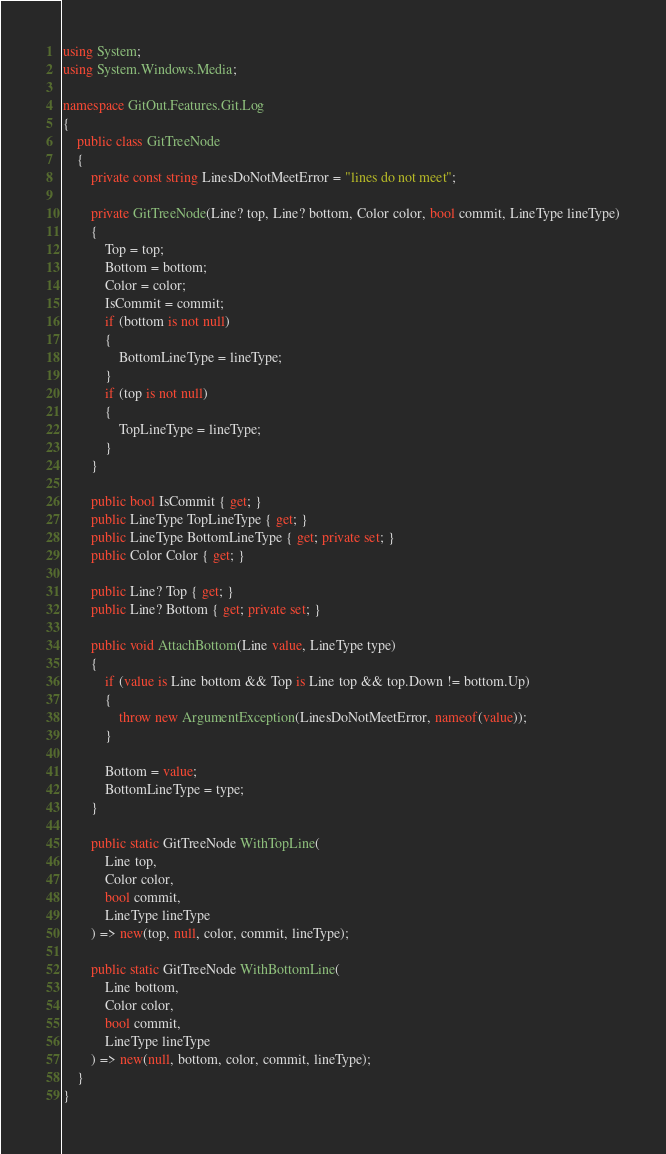<code> <loc_0><loc_0><loc_500><loc_500><_C#_>using System;
using System.Windows.Media;

namespace GitOut.Features.Git.Log
{
    public class GitTreeNode
    {
        private const string LinesDoNotMeetError = "lines do not meet";

        private GitTreeNode(Line? top, Line? bottom, Color color, bool commit, LineType lineType)
        {
            Top = top;
            Bottom = bottom;
            Color = color;
            IsCommit = commit;
            if (bottom is not null)
            {
                BottomLineType = lineType;
            }
            if (top is not null)
            {
                TopLineType = lineType;
            }
        }

        public bool IsCommit { get; }
        public LineType TopLineType { get; }
        public LineType BottomLineType { get; private set; }
        public Color Color { get; }

        public Line? Top { get; }
        public Line? Bottom { get; private set; }

        public void AttachBottom(Line value, LineType type)
        {
            if (value is Line bottom && Top is Line top && top.Down != bottom.Up)
            {
                throw new ArgumentException(LinesDoNotMeetError, nameof(value));
            }

            Bottom = value;
            BottomLineType = type;
        }

        public static GitTreeNode WithTopLine(
            Line top,
            Color color,
            bool commit,
            LineType lineType
        ) => new(top, null, color, commit, lineType);

        public static GitTreeNode WithBottomLine(
            Line bottom,
            Color color,
            bool commit,
            LineType lineType
        ) => new(null, bottom, color, commit, lineType);
    }
}
</code> 